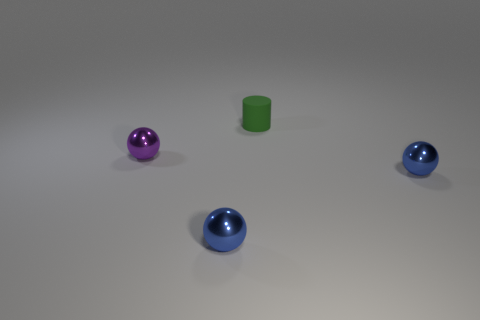Is there a purple metallic object that has the same size as the rubber object?
Make the answer very short. Yes. The metallic ball behind the blue ball on the right side of the object that is behind the purple metallic ball is what color?
Offer a very short reply. Purple. Do the small cylinder and the sphere that is on the right side of the tiny matte cylinder have the same material?
Provide a succinct answer. No. Are there an equal number of metallic things to the right of the small purple metal sphere and purple balls in front of the matte thing?
Your answer should be very brief. No. What number of other objects are there of the same material as the tiny purple object?
Offer a terse response. 2. Are there the same number of small spheres behind the green cylinder and small green rubber cylinders?
Your answer should be very brief. No. There is a purple shiny ball; is its size the same as the thing behind the purple metal thing?
Make the answer very short. Yes. What shape is the small thing that is behind the purple metallic ball?
Offer a very short reply. Cylinder. Are there any other things that have the same shape as the purple metal thing?
Ensure brevity in your answer.  Yes. Are any green matte cylinders visible?
Give a very brief answer. Yes. 